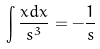<formula> <loc_0><loc_0><loc_500><loc_500>\int \frac { x d x } { s ^ { 3 } } = - \frac { 1 } { s }</formula> 